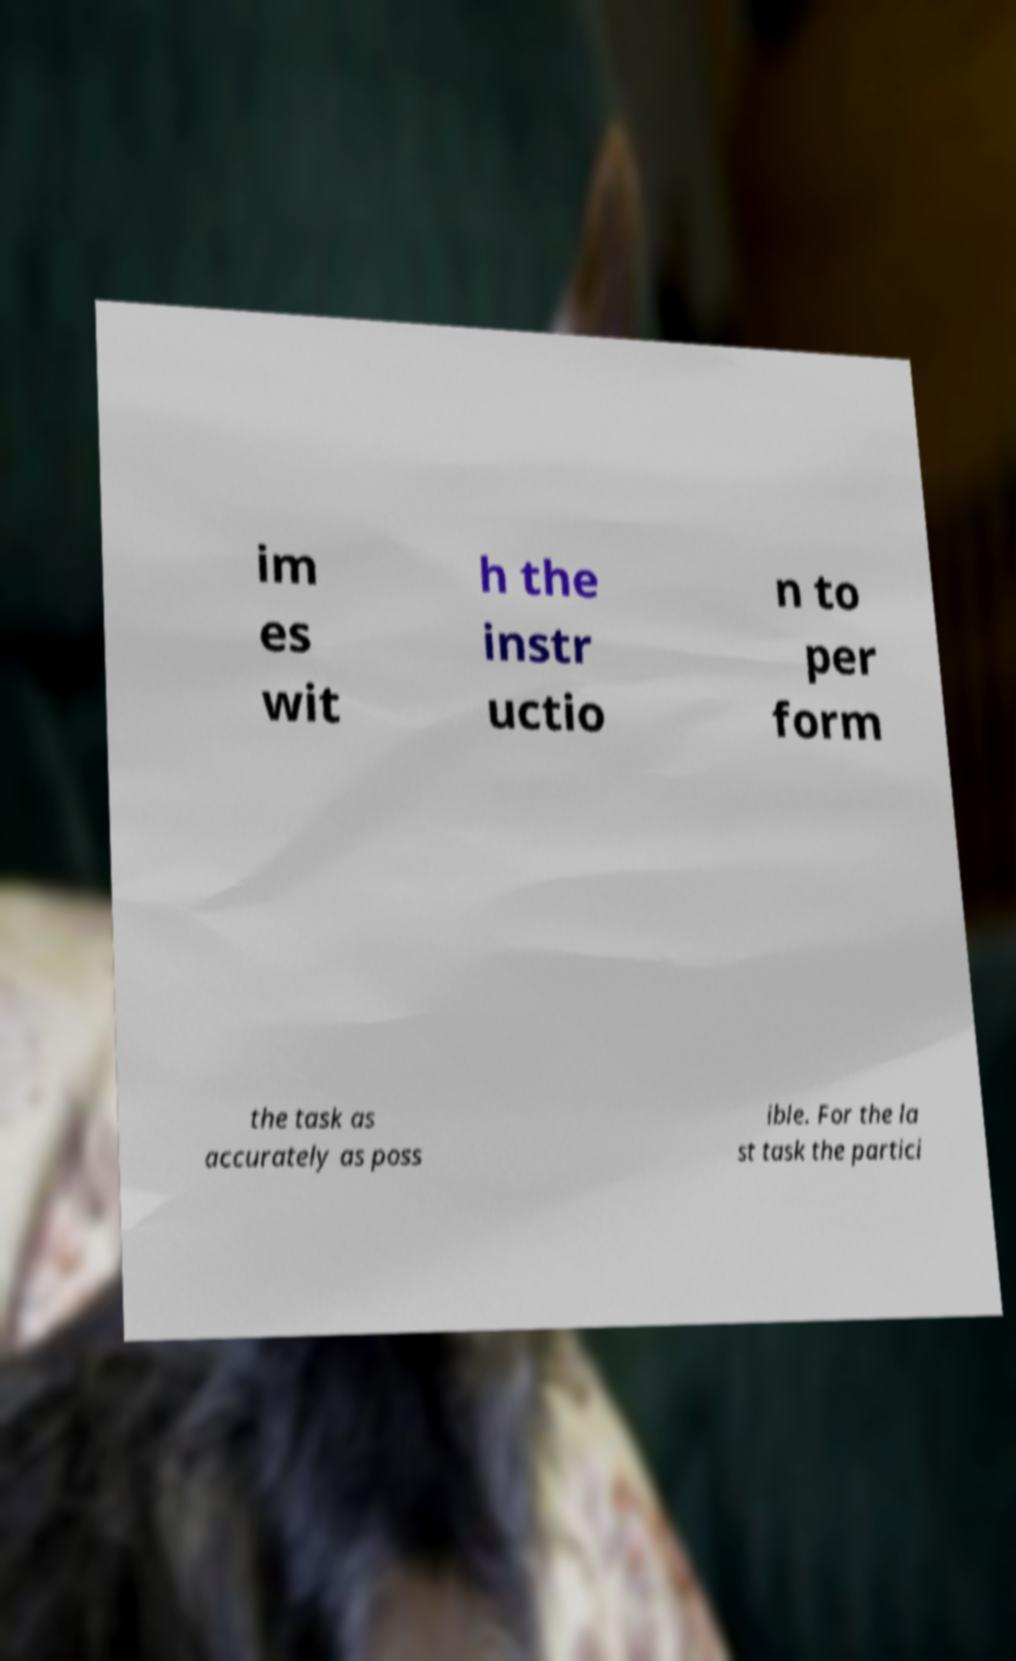What messages or text are displayed in this image? I need them in a readable, typed format. im es wit h the instr uctio n to per form the task as accurately as poss ible. For the la st task the partici 